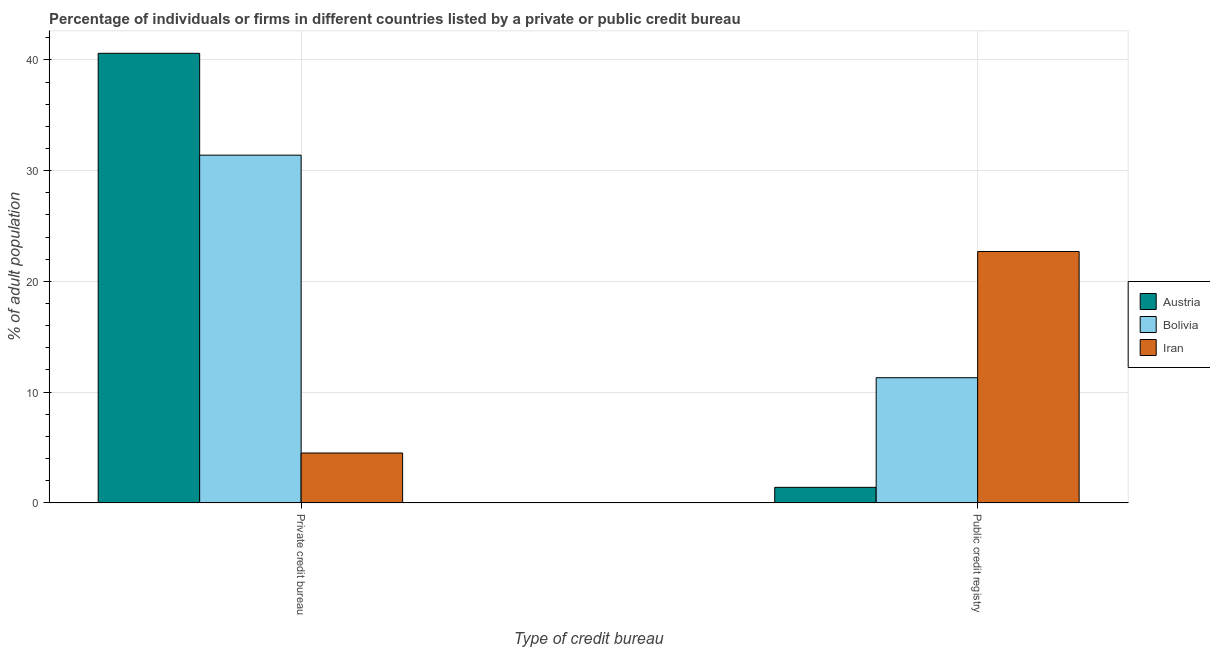How many groups of bars are there?
Make the answer very short. 2. Are the number of bars on each tick of the X-axis equal?
Make the answer very short. Yes. How many bars are there on the 1st tick from the right?
Provide a succinct answer. 3. What is the label of the 1st group of bars from the left?
Your answer should be compact. Private credit bureau. What is the percentage of firms listed by private credit bureau in Bolivia?
Give a very brief answer. 31.4. Across all countries, what is the maximum percentage of firms listed by public credit bureau?
Provide a short and direct response. 22.7. In which country was the percentage of firms listed by public credit bureau maximum?
Offer a very short reply. Iran. In which country was the percentage of firms listed by public credit bureau minimum?
Offer a terse response. Austria. What is the total percentage of firms listed by private credit bureau in the graph?
Ensure brevity in your answer.  76.5. What is the difference between the percentage of firms listed by private credit bureau in Bolivia and that in Austria?
Offer a terse response. -9.2. What is the difference between the percentage of firms listed by private credit bureau in Iran and the percentage of firms listed by public credit bureau in Bolivia?
Your response must be concise. -6.8. What is the average percentage of firms listed by private credit bureau per country?
Make the answer very short. 25.5. What is the difference between the percentage of firms listed by public credit bureau and percentage of firms listed by private credit bureau in Bolivia?
Your response must be concise. -20.1. In how many countries, is the percentage of firms listed by public credit bureau greater than 12 %?
Your response must be concise. 1. What is the ratio of the percentage of firms listed by public credit bureau in Iran to that in Austria?
Your answer should be very brief. 16.21. Is the percentage of firms listed by private credit bureau in Austria less than that in Bolivia?
Your answer should be very brief. No. What does the 1st bar from the left in Private credit bureau represents?
Make the answer very short. Austria. What does the 1st bar from the right in Public credit registry represents?
Provide a succinct answer. Iran. How many bars are there?
Make the answer very short. 6. How many countries are there in the graph?
Your answer should be compact. 3. What is the difference between two consecutive major ticks on the Y-axis?
Provide a short and direct response. 10. Does the graph contain grids?
Make the answer very short. Yes. Where does the legend appear in the graph?
Provide a succinct answer. Center right. What is the title of the graph?
Provide a succinct answer. Percentage of individuals or firms in different countries listed by a private or public credit bureau. What is the label or title of the X-axis?
Your response must be concise. Type of credit bureau. What is the label or title of the Y-axis?
Your answer should be compact. % of adult population. What is the % of adult population in Austria in Private credit bureau?
Make the answer very short. 40.6. What is the % of adult population in Bolivia in Private credit bureau?
Your response must be concise. 31.4. What is the % of adult population of Bolivia in Public credit registry?
Give a very brief answer. 11.3. What is the % of adult population of Iran in Public credit registry?
Your answer should be compact. 22.7. Across all Type of credit bureau, what is the maximum % of adult population of Austria?
Your answer should be compact. 40.6. Across all Type of credit bureau, what is the maximum % of adult population of Bolivia?
Your answer should be compact. 31.4. Across all Type of credit bureau, what is the maximum % of adult population of Iran?
Provide a short and direct response. 22.7. What is the total % of adult population in Austria in the graph?
Keep it short and to the point. 42. What is the total % of adult population in Bolivia in the graph?
Offer a very short reply. 42.7. What is the total % of adult population in Iran in the graph?
Provide a succinct answer. 27.2. What is the difference between the % of adult population of Austria in Private credit bureau and that in Public credit registry?
Provide a short and direct response. 39.2. What is the difference between the % of adult population of Bolivia in Private credit bureau and that in Public credit registry?
Provide a short and direct response. 20.1. What is the difference between the % of adult population of Iran in Private credit bureau and that in Public credit registry?
Provide a succinct answer. -18.2. What is the difference between the % of adult population in Austria in Private credit bureau and the % of adult population in Bolivia in Public credit registry?
Your answer should be compact. 29.3. What is the difference between the % of adult population in Austria in Private credit bureau and the % of adult population in Iran in Public credit registry?
Keep it short and to the point. 17.9. What is the average % of adult population in Bolivia per Type of credit bureau?
Provide a short and direct response. 21.35. What is the difference between the % of adult population of Austria and % of adult population of Iran in Private credit bureau?
Keep it short and to the point. 36.1. What is the difference between the % of adult population in Bolivia and % of adult population in Iran in Private credit bureau?
Your answer should be compact. 26.9. What is the difference between the % of adult population of Austria and % of adult population of Bolivia in Public credit registry?
Your answer should be compact. -9.9. What is the difference between the % of adult population in Austria and % of adult population in Iran in Public credit registry?
Keep it short and to the point. -21.3. What is the difference between the % of adult population of Bolivia and % of adult population of Iran in Public credit registry?
Your answer should be compact. -11.4. What is the ratio of the % of adult population of Bolivia in Private credit bureau to that in Public credit registry?
Your response must be concise. 2.78. What is the ratio of the % of adult population of Iran in Private credit bureau to that in Public credit registry?
Your answer should be very brief. 0.2. What is the difference between the highest and the second highest % of adult population in Austria?
Your answer should be very brief. 39.2. What is the difference between the highest and the second highest % of adult population in Bolivia?
Your answer should be compact. 20.1. What is the difference between the highest and the second highest % of adult population in Iran?
Your answer should be compact. 18.2. What is the difference between the highest and the lowest % of adult population in Austria?
Ensure brevity in your answer.  39.2. What is the difference between the highest and the lowest % of adult population in Bolivia?
Offer a terse response. 20.1. What is the difference between the highest and the lowest % of adult population in Iran?
Your answer should be very brief. 18.2. 